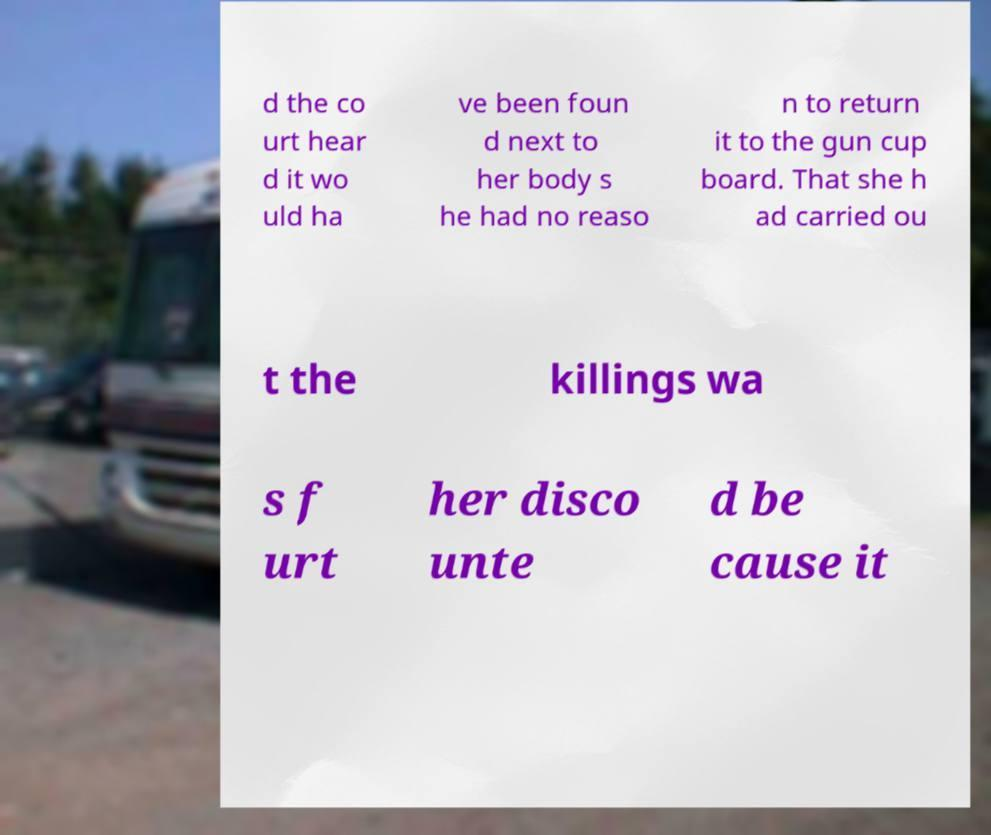Could you extract and type out the text from this image? d the co urt hear d it wo uld ha ve been foun d next to her body s he had no reaso n to return it to the gun cup board. That she h ad carried ou t the killings wa s f urt her disco unte d be cause it 